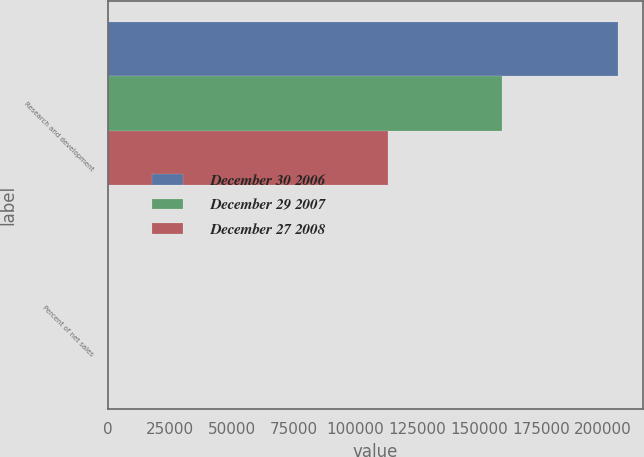<chart> <loc_0><loc_0><loc_500><loc_500><stacked_bar_chart><ecel><fcel>Research and development<fcel>Percent of net sales<nl><fcel>December 30 2006<fcel>206109<fcel>5.9<nl><fcel>December 29 2007<fcel>159406<fcel>5<nl><fcel>December 27 2008<fcel>113314<fcel>6.4<nl></chart> 